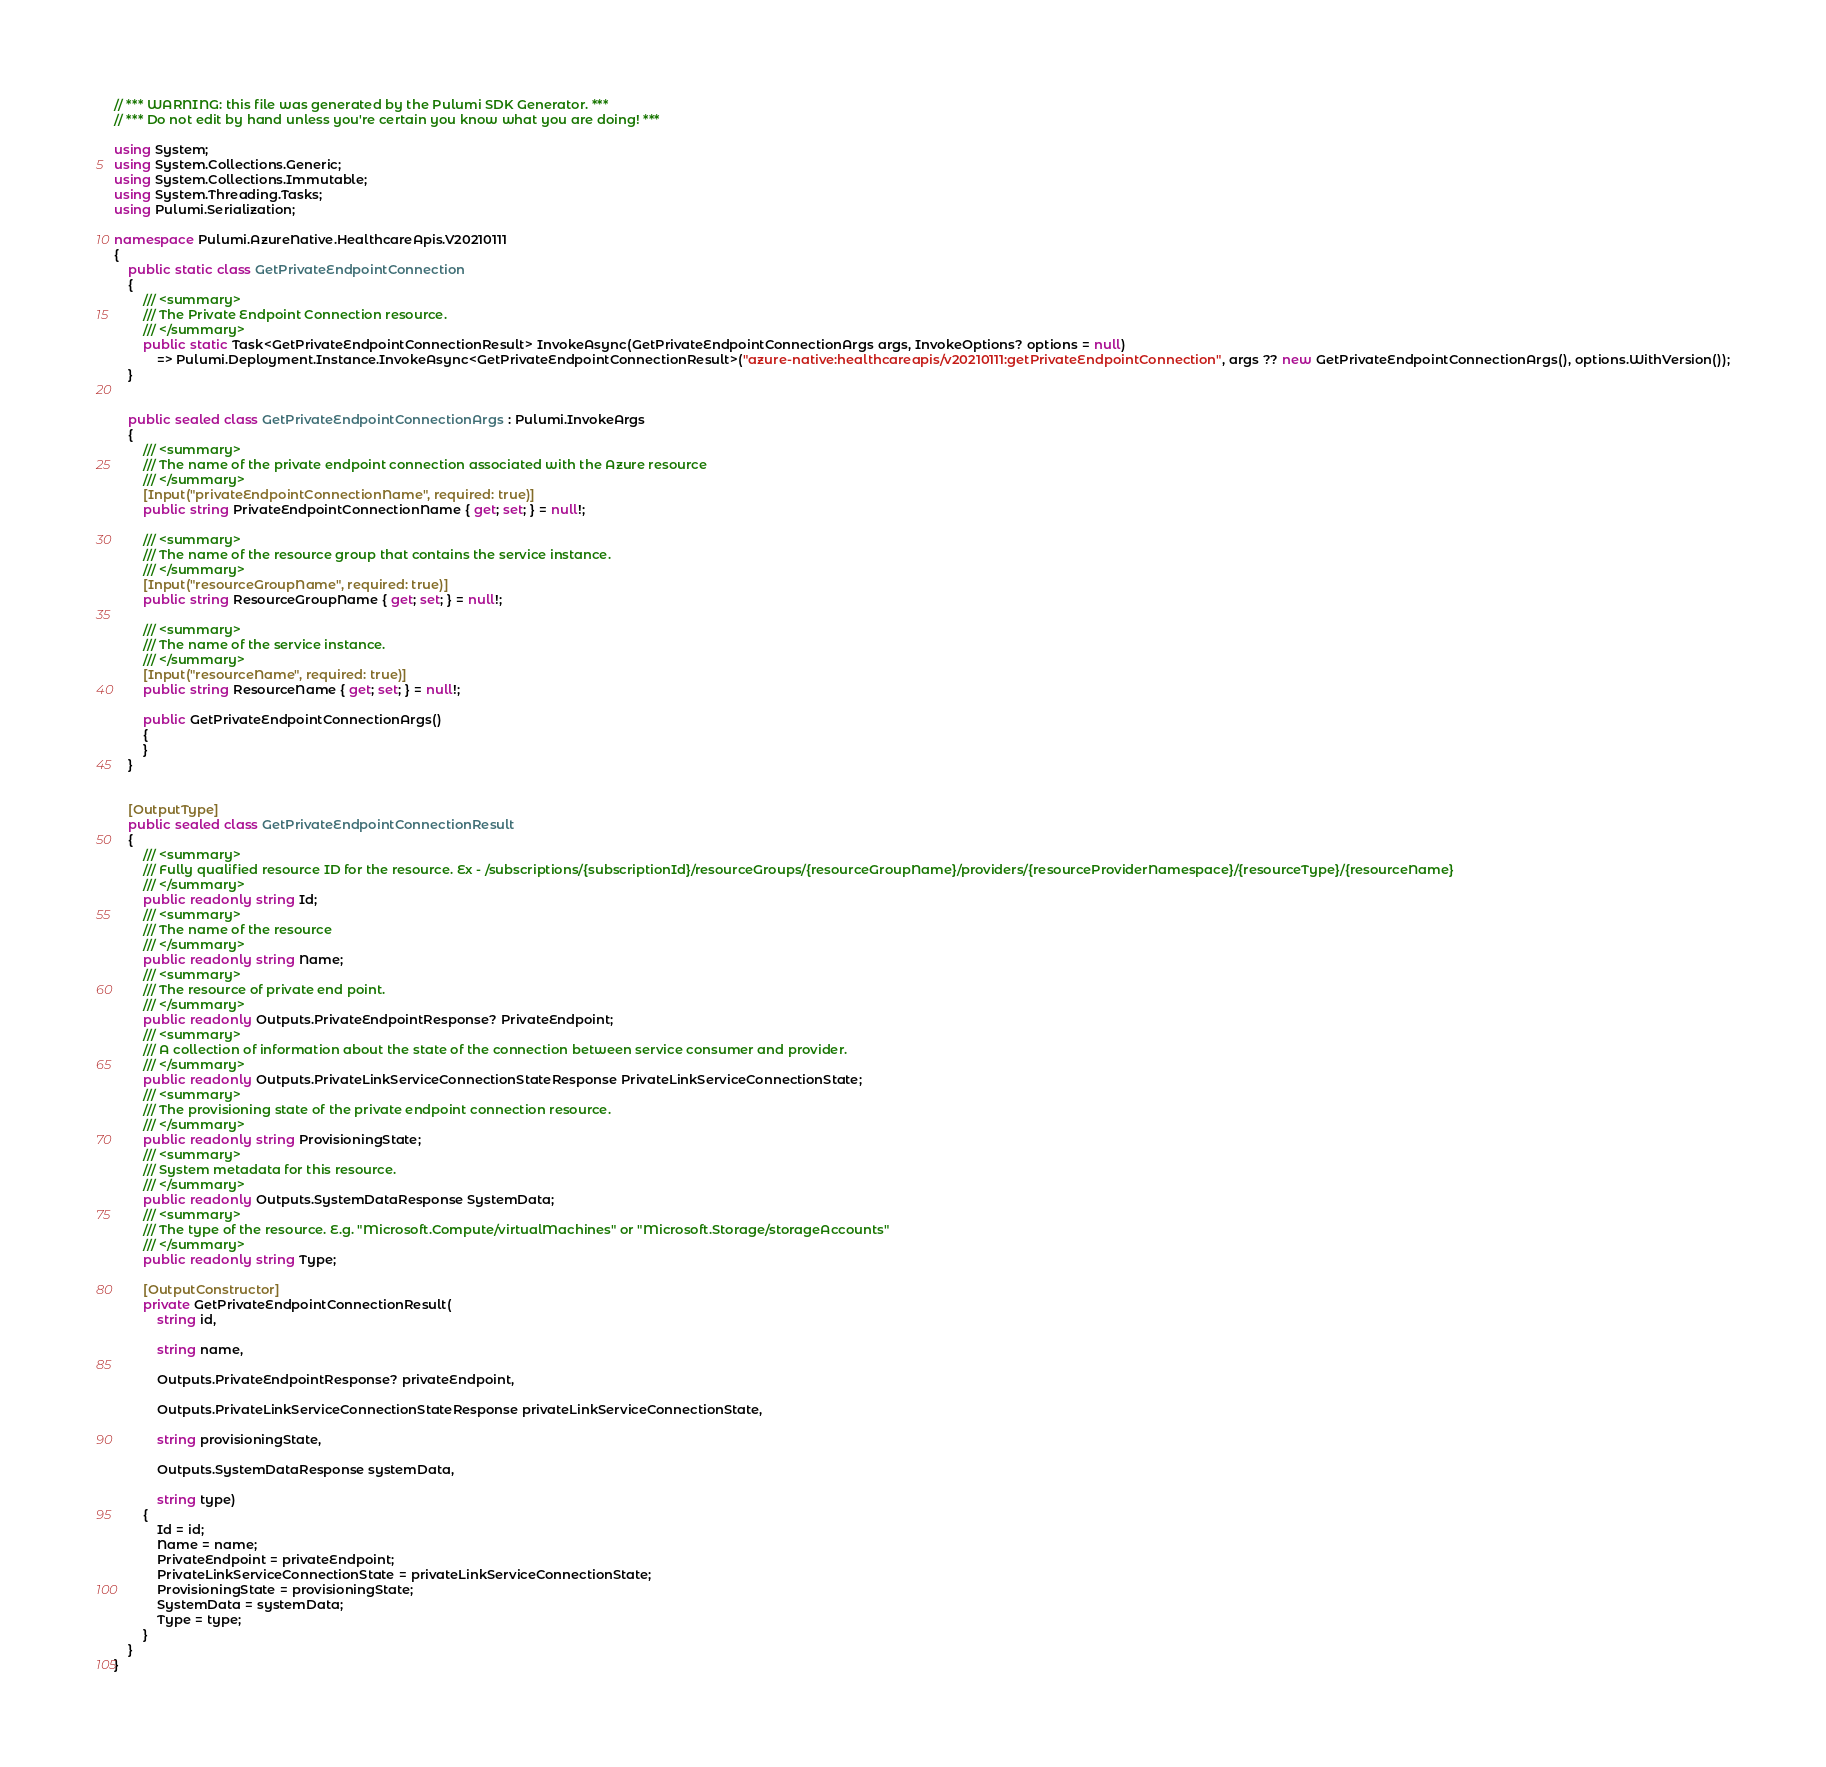Convert code to text. <code><loc_0><loc_0><loc_500><loc_500><_C#_>// *** WARNING: this file was generated by the Pulumi SDK Generator. ***
// *** Do not edit by hand unless you're certain you know what you are doing! ***

using System;
using System.Collections.Generic;
using System.Collections.Immutable;
using System.Threading.Tasks;
using Pulumi.Serialization;

namespace Pulumi.AzureNative.HealthcareApis.V20210111
{
    public static class GetPrivateEndpointConnection
    {
        /// <summary>
        /// The Private Endpoint Connection resource.
        /// </summary>
        public static Task<GetPrivateEndpointConnectionResult> InvokeAsync(GetPrivateEndpointConnectionArgs args, InvokeOptions? options = null)
            => Pulumi.Deployment.Instance.InvokeAsync<GetPrivateEndpointConnectionResult>("azure-native:healthcareapis/v20210111:getPrivateEndpointConnection", args ?? new GetPrivateEndpointConnectionArgs(), options.WithVersion());
    }


    public sealed class GetPrivateEndpointConnectionArgs : Pulumi.InvokeArgs
    {
        /// <summary>
        /// The name of the private endpoint connection associated with the Azure resource
        /// </summary>
        [Input("privateEndpointConnectionName", required: true)]
        public string PrivateEndpointConnectionName { get; set; } = null!;

        /// <summary>
        /// The name of the resource group that contains the service instance.
        /// </summary>
        [Input("resourceGroupName", required: true)]
        public string ResourceGroupName { get; set; } = null!;

        /// <summary>
        /// The name of the service instance.
        /// </summary>
        [Input("resourceName", required: true)]
        public string ResourceName { get; set; } = null!;

        public GetPrivateEndpointConnectionArgs()
        {
        }
    }


    [OutputType]
    public sealed class GetPrivateEndpointConnectionResult
    {
        /// <summary>
        /// Fully qualified resource ID for the resource. Ex - /subscriptions/{subscriptionId}/resourceGroups/{resourceGroupName}/providers/{resourceProviderNamespace}/{resourceType}/{resourceName}
        /// </summary>
        public readonly string Id;
        /// <summary>
        /// The name of the resource
        /// </summary>
        public readonly string Name;
        /// <summary>
        /// The resource of private end point.
        /// </summary>
        public readonly Outputs.PrivateEndpointResponse? PrivateEndpoint;
        /// <summary>
        /// A collection of information about the state of the connection between service consumer and provider.
        /// </summary>
        public readonly Outputs.PrivateLinkServiceConnectionStateResponse PrivateLinkServiceConnectionState;
        /// <summary>
        /// The provisioning state of the private endpoint connection resource.
        /// </summary>
        public readonly string ProvisioningState;
        /// <summary>
        /// System metadata for this resource.
        /// </summary>
        public readonly Outputs.SystemDataResponse SystemData;
        /// <summary>
        /// The type of the resource. E.g. "Microsoft.Compute/virtualMachines" or "Microsoft.Storage/storageAccounts"
        /// </summary>
        public readonly string Type;

        [OutputConstructor]
        private GetPrivateEndpointConnectionResult(
            string id,

            string name,

            Outputs.PrivateEndpointResponse? privateEndpoint,

            Outputs.PrivateLinkServiceConnectionStateResponse privateLinkServiceConnectionState,

            string provisioningState,

            Outputs.SystemDataResponse systemData,

            string type)
        {
            Id = id;
            Name = name;
            PrivateEndpoint = privateEndpoint;
            PrivateLinkServiceConnectionState = privateLinkServiceConnectionState;
            ProvisioningState = provisioningState;
            SystemData = systemData;
            Type = type;
        }
    }
}
</code> 